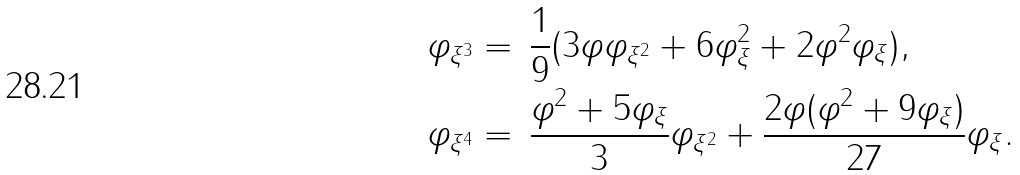Convert formula to latex. <formula><loc_0><loc_0><loc_500><loc_500>\varphi _ { \xi ^ { 3 } } & = \, \frac { 1 } { 9 } ( 3 \varphi \varphi _ { \xi ^ { 2 } } + 6 \varphi _ { \xi } ^ { 2 } + 2 \varphi ^ { 2 } \varphi _ { \xi } ) , \\ \varphi _ { \xi ^ { 4 } } & = \, \frac { \varphi ^ { 2 } + 5 \varphi _ { \xi } } { 3 } \varphi _ { \xi ^ { 2 } } + \frac { 2 \varphi ( \varphi ^ { 2 } + 9 \varphi _ { \xi } ) } { 2 7 } \varphi _ { \xi } .</formula> 